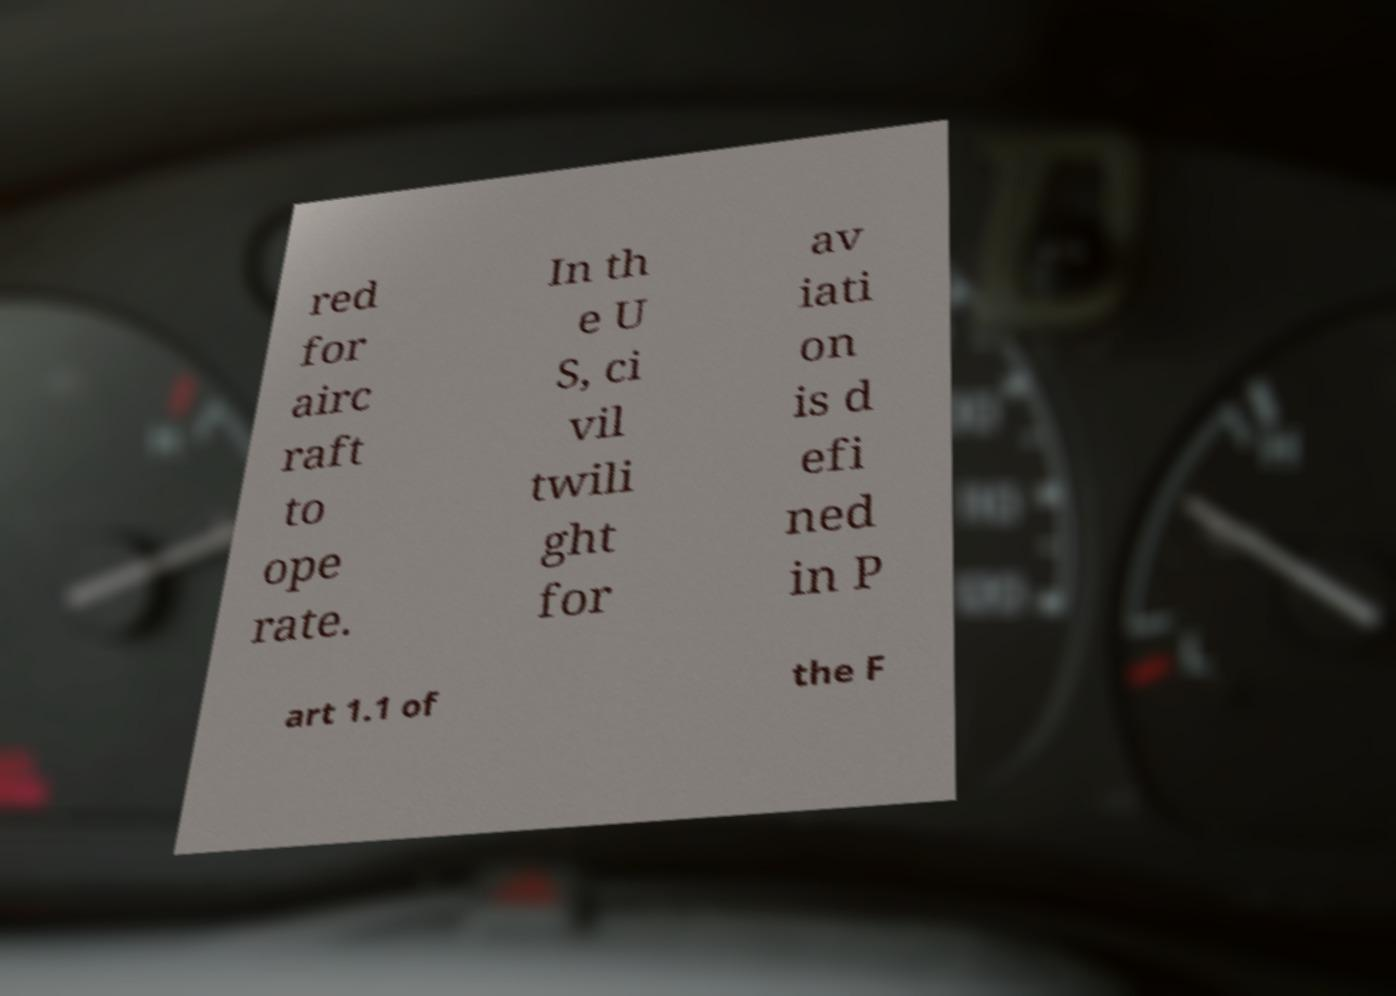There's text embedded in this image that I need extracted. Can you transcribe it verbatim? red for airc raft to ope rate. In th e U S, ci vil twili ght for av iati on is d efi ned in P art 1.1 of the F 